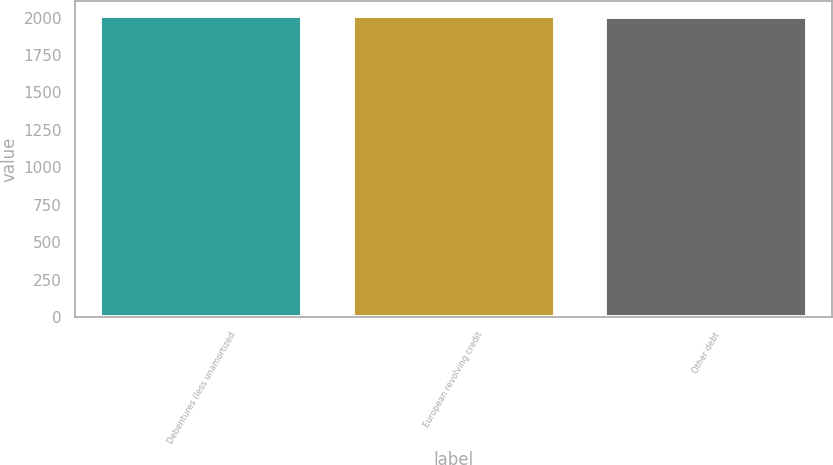Convert chart. <chart><loc_0><loc_0><loc_500><loc_500><bar_chart><fcel>Debentures (less unamortized<fcel>European revolving credit<fcel>Other debt<nl><fcel>2011<fcel>2010<fcel>2007<nl></chart> 